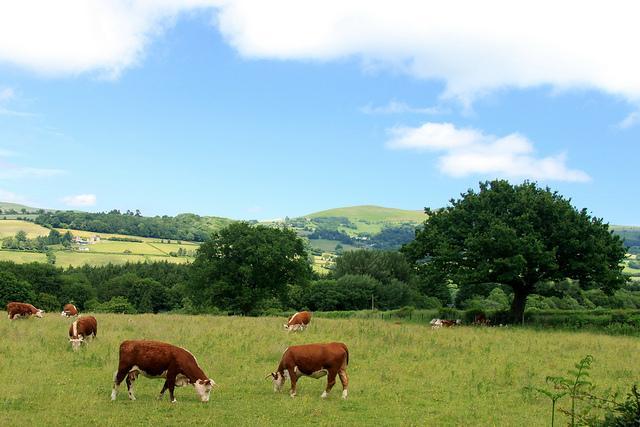These animals usually live where?

Choices:
A) cave
B) underground hole
C) pasture
D) tundra pasture 